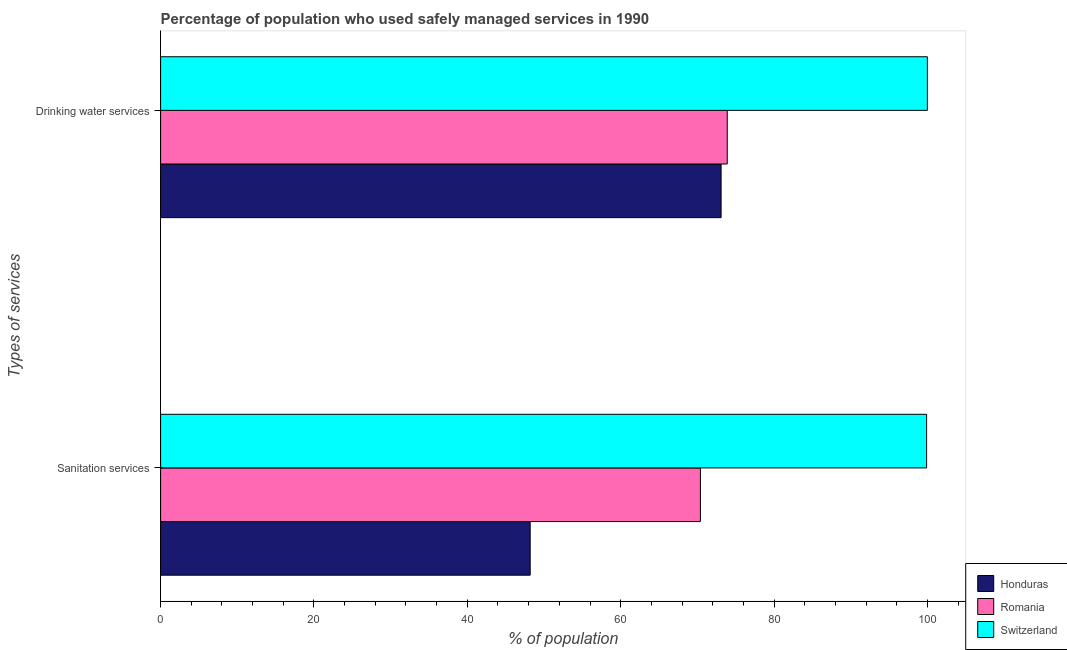How many different coloured bars are there?
Give a very brief answer. 3. Are the number of bars per tick equal to the number of legend labels?
Keep it short and to the point. Yes. How many bars are there on the 1st tick from the bottom?
Offer a very short reply. 3. What is the label of the 2nd group of bars from the top?
Offer a very short reply. Sanitation services. What is the percentage of population who used drinking water services in Romania?
Your answer should be very brief. 73.9. Across all countries, what is the minimum percentage of population who used drinking water services?
Give a very brief answer. 73.1. In which country was the percentage of population who used sanitation services maximum?
Ensure brevity in your answer.  Switzerland. In which country was the percentage of population who used drinking water services minimum?
Offer a terse response. Honduras. What is the total percentage of population who used drinking water services in the graph?
Ensure brevity in your answer.  247. What is the difference between the percentage of population who used drinking water services in Romania and that in Switzerland?
Make the answer very short. -26.1. What is the difference between the percentage of population who used sanitation services in Honduras and the percentage of population who used drinking water services in Switzerland?
Provide a short and direct response. -51.8. What is the average percentage of population who used drinking water services per country?
Your answer should be compact. 82.33. What is the ratio of the percentage of population who used drinking water services in Romania to that in Switzerland?
Make the answer very short. 0.74. What does the 3rd bar from the top in Drinking water services represents?
Provide a succinct answer. Honduras. What does the 2nd bar from the bottom in Drinking water services represents?
Your response must be concise. Romania. What is the difference between two consecutive major ticks on the X-axis?
Offer a very short reply. 20. Are the values on the major ticks of X-axis written in scientific E-notation?
Ensure brevity in your answer.  No. Does the graph contain grids?
Give a very brief answer. No. How many legend labels are there?
Provide a short and direct response. 3. What is the title of the graph?
Your answer should be compact. Percentage of population who used safely managed services in 1990. What is the label or title of the X-axis?
Keep it short and to the point. % of population. What is the label or title of the Y-axis?
Give a very brief answer. Types of services. What is the % of population of Honduras in Sanitation services?
Provide a short and direct response. 48.2. What is the % of population in Romania in Sanitation services?
Give a very brief answer. 70.4. What is the % of population in Switzerland in Sanitation services?
Your answer should be very brief. 99.9. What is the % of population of Honduras in Drinking water services?
Offer a terse response. 73.1. What is the % of population in Romania in Drinking water services?
Your answer should be compact. 73.9. What is the % of population in Switzerland in Drinking water services?
Keep it short and to the point. 100. Across all Types of services, what is the maximum % of population in Honduras?
Give a very brief answer. 73.1. Across all Types of services, what is the maximum % of population of Romania?
Provide a short and direct response. 73.9. Across all Types of services, what is the maximum % of population of Switzerland?
Make the answer very short. 100. Across all Types of services, what is the minimum % of population in Honduras?
Provide a short and direct response. 48.2. Across all Types of services, what is the minimum % of population in Romania?
Give a very brief answer. 70.4. Across all Types of services, what is the minimum % of population in Switzerland?
Your answer should be compact. 99.9. What is the total % of population of Honduras in the graph?
Offer a very short reply. 121.3. What is the total % of population in Romania in the graph?
Give a very brief answer. 144.3. What is the total % of population of Switzerland in the graph?
Give a very brief answer. 199.9. What is the difference between the % of population of Honduras in Sanitation services and that in Drinking water services?
Your response must be concise. -24.9. What is the difference between the % of population in Switzerland in Sanitation services and that in Drinking water services?
Make the answer very short. -0.1. What is the difference between the % of population in Honduras in Sanitation services and the % of population in Romania in Drinking water services?
Offer a very short reply. -25.7. What is the difference between the % of population of Honduras in Sanitation services and the % of population of Switzerland in Drinking water services?
Your answer should be compact. -51.8. What is the difference between the % of population of Romania in Sanitation services and the % of population of Switzerland in Drinking water services?
Offer a very short reply. -29.6. What is the average % of population in Honduras per Types of services?
Provide a short and direct response. 60.65. What is the average % of population of Romania per Types of services?
Give a very brief answer. 72.15. What is the average % of population in Switzerland per Types of services?
Offer a very short reply. 99.95. What is the difference between the % of population in Honduras and % of population in Romania in Sanitation services?
Give a very brief answer. -22.2. What is the difference between the % of population of Honduras and % of population of Switzerland in Sanitation services?
Your response must be concise. -51.7. What is the difference between the % of population of Romania and % of population of Switzerland in Sanitation services?
Keep it short and to the point. -29.5. What is the difference between the % of population of Honduras and % of population of Switzerland in Drinking water services?
Your answer should be very brief. -26.9. What is the difference between the % of population in Romania and % of population in Switzerland in Drinking water services?
Provide a short and direct response. -26.1. What is the ratio of the % of population in Honduras in Sanitation services to that in Drinking water services?
Offer a terse response. 0.66. What is the ratio of the % of population in Romania in Sanitation services to that in Drinking water services?
Give a very brief answer. 0.95. What is the difference between the highest and the second highest % of population in Honduras?
Provide a short and direct response. 24.9. What is the difference between the highest and the second highest % of population in Switzerland?
Ensure brevity in your answer.  0.1. What is the difference between the highest and the lowest % of population of Honduras?
Make the answer very short. 24.9. What is the difference between the highest and the lowest % of population in Romania?
Provide a short and direct response. 3.5. What is the difference between the highest and the lowest % of population of Switzerland?
Ensure brevity in your answer.  0.1. 